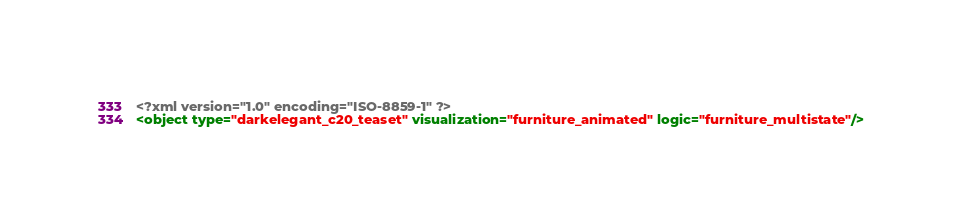Convert code to text. <code><loc_0><loc_0><loc_500><loc_500><_XML_><?xml version="1.0" encoding="ISO-8859-1" ?><object type="darkelegant_c20_teaset" visualization="furniture_animated" logic="furniture_multistate"/></code> 